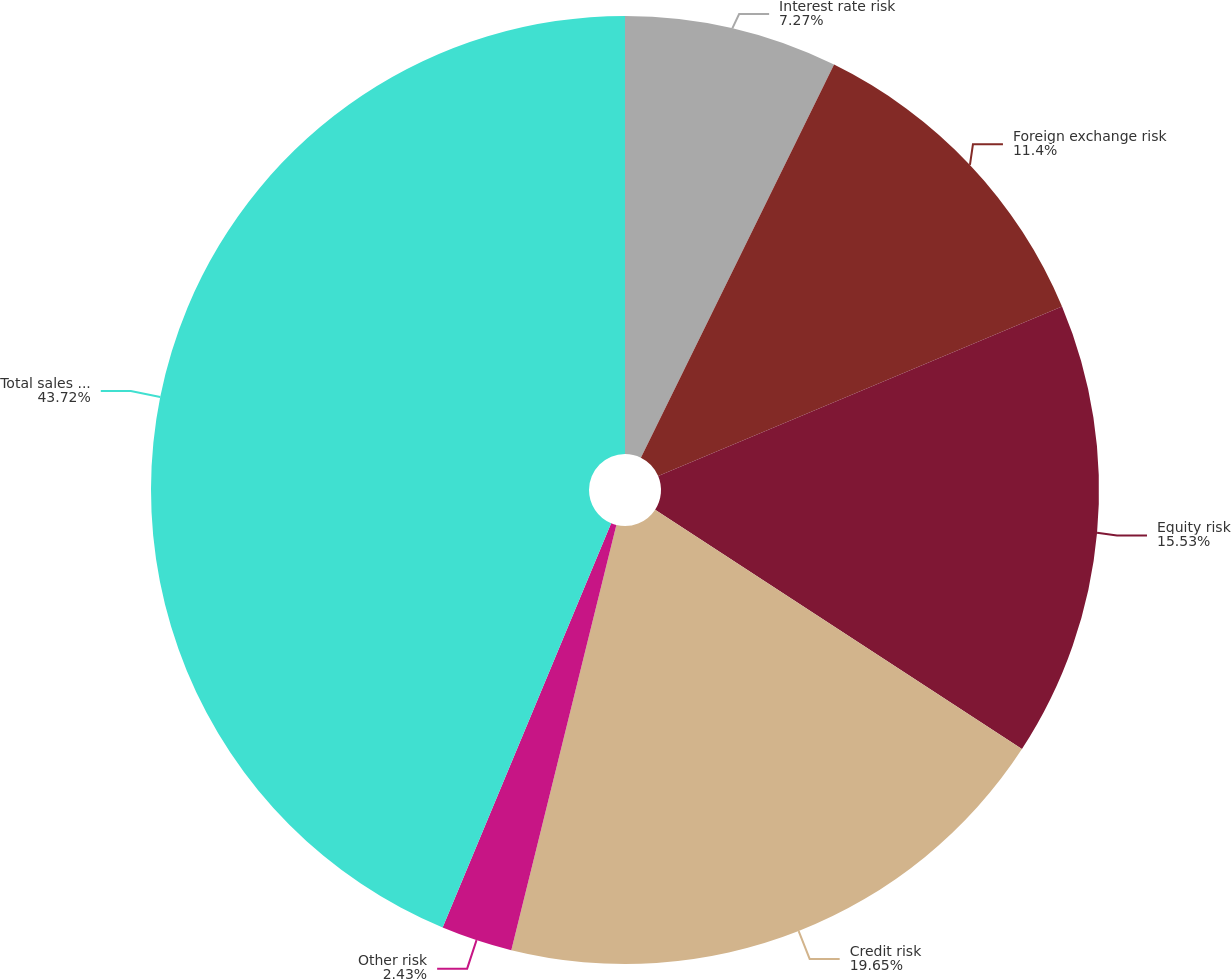Convert chart to OTSL. <chart><loc_0><loc_0><loc_500><loc_500><pie_chart><fcel>Interest rate risk<fcel>Foreign exchange risk<fcel>Equity risk<fcel>Credit risk<fcel>Other risk<fcel>Total sales and trading<nl><fcel>7.27%<fcel>11.4%<fcel>15.53%<fcel>19.65%<fcel>2.43%<fcel>43.71%<nl></chart> 